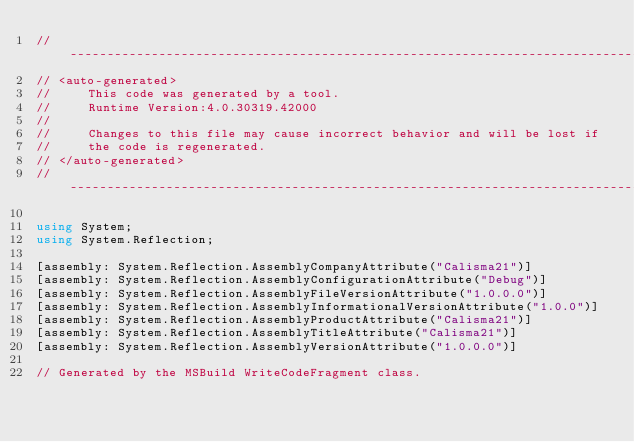<code> <loc_0><loc_0><loc_500><loc_500><_C#_>//------------------------------------------------------------------------------
// <auto-generated>
//     This code was generated by a tool.
//     Runtime Version:4.0.30319.42000
//
//     Changes to this file may cause incorrect behavior and will be lost if
//     the code is regenerated.
// </auto-generated>
//------------------------------------------------------------------------------

using System;
using System.Reflection;

[assembly: System.Reflection.AssemblyCompanyAttribute("Calisma21")]
[assembly: System.Reflection.AssemblyConfigurationAttribute("Debug")]
[assembly: System.Reflection.AssemblyFileVersionAttribute("1.0.0.0")]
[assembly: System.Reflection.AssemblyInformationalVersionAttribute("1.0.0")]
[assembly: System.Reflection.AssemblyProductAttribute("Calisma21")]
[assembly: System.Reflection.AssemblyTitleAttribute("Calisma21")]
[assembly: System.Reflection.AssemblyVersionAttribute("1.0.0.0")]

// Generated by the MSBuild WriteCodeFragment class.

</code> 